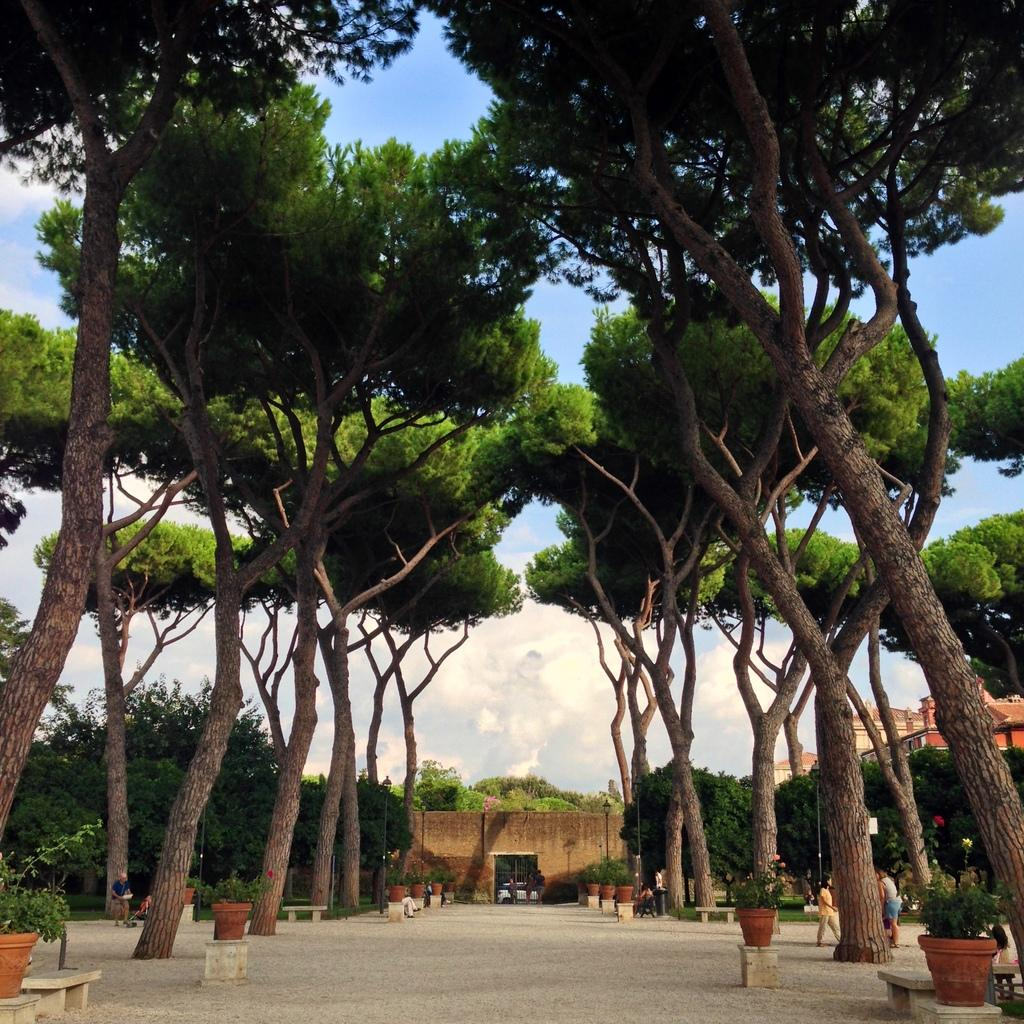What can be seen in the sky in the image? The sky is visible in the image, and clouds are present. What type of structures are in the image? There are buildings in the image. What type of vegetation is present in the image? Trees, plants, and grass are visible in the image. What type of containers are in the image? Plant pots are in the image. What type of seating is in the image? Benches are in the image. Are there any people in the image? Yes, there are people standing in the image. What type of underwear is visible on the people in the image? There is no information about the people's underwear in the image, and therefore it cannot be determined. What type of smell can be detected in the image? There is no information about smells in the image, and therefore it cannot be determined. 